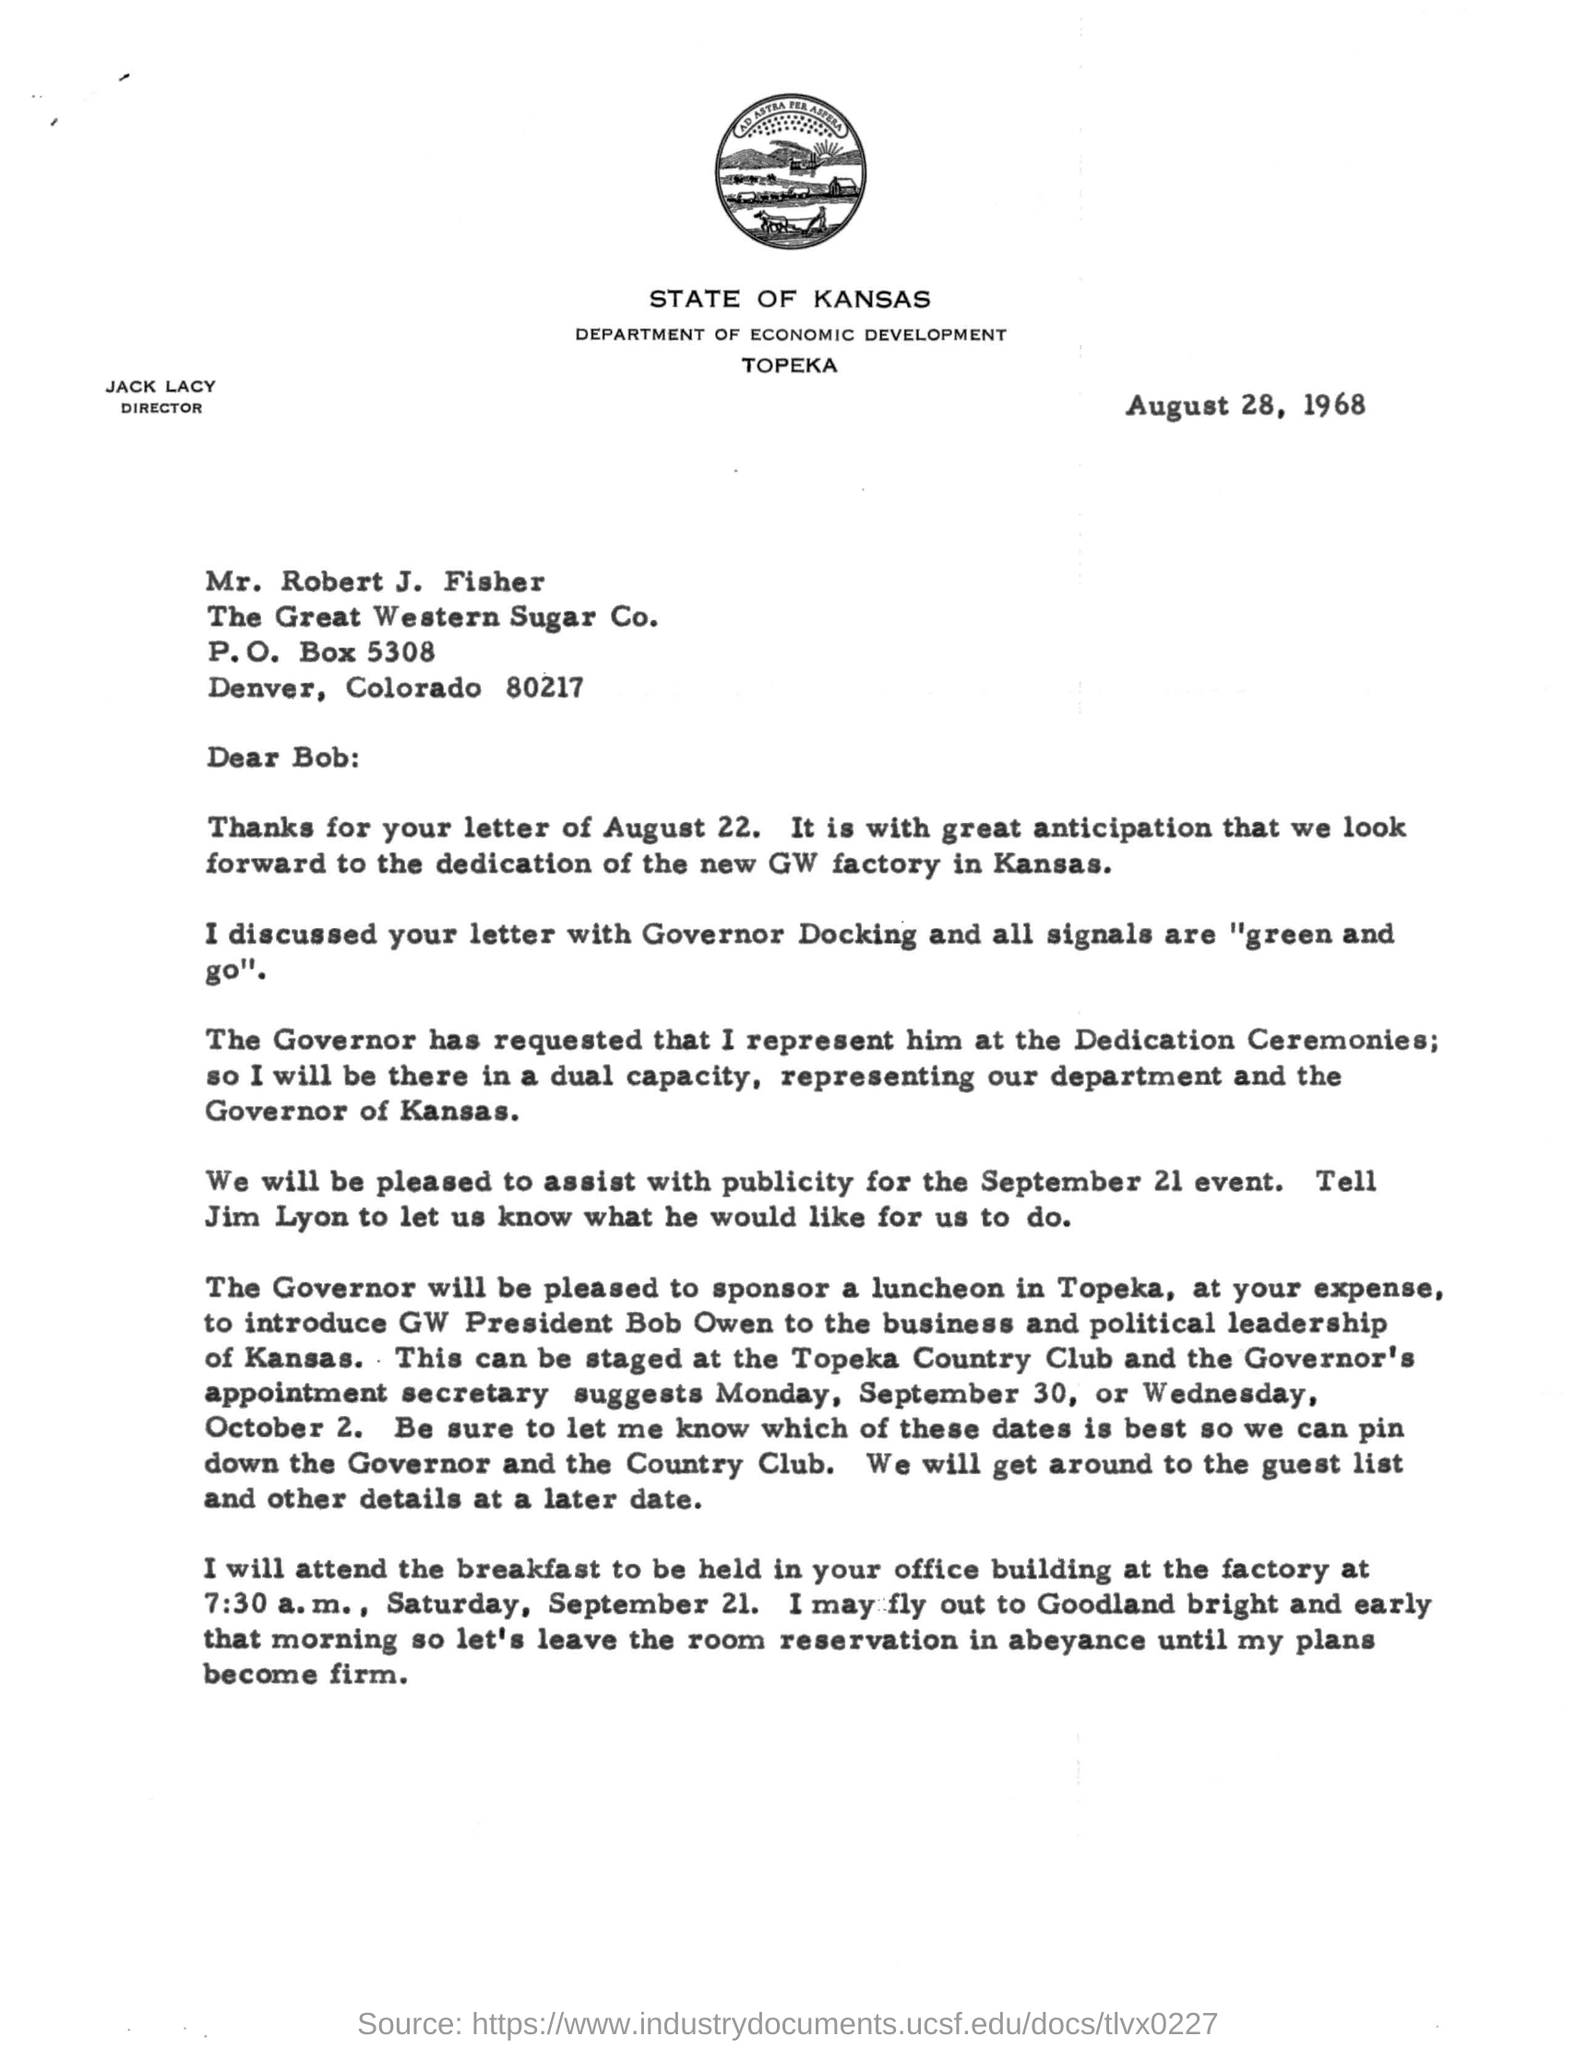Outline some significant characteristics in this image. The director's name is Jack Lacy. The company name is The Great Western Sugar Company. What is the P.O.Box number? It is 5308. The heading of this document is 'STATE OF KANSAS..'. 